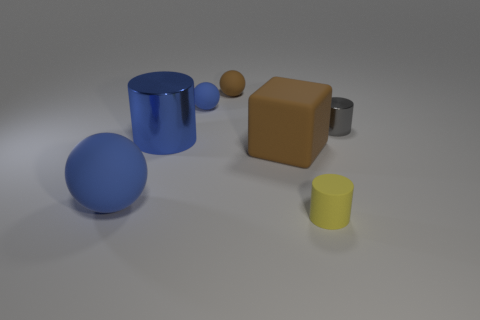Do the metal object that is in front of the gray shiny object and the tiny blue object have the same size?
Your response must be concise. No. Is the small metallic thing the same color as the big block?
Give a very brief answer. No. How many objects are things that are in front of the small brown sphere or blue objects?
Give a very brief answer. 6. What color is the large object that is the same shape as the tiny brown rubber thing?
Your answer should be compact. Blue. Does the big brown rubber object have the same shape as the small thing that is in front of the large blue ball?
Offer a very short reply. No. What number of objects are cylinders in front of the big metal cylinder or metal cylinders right of the large metallic cylinder?
Keep it short and to the point. 2. Are there fewer large brown objects that are in front of the large ball than small purple rubber balls?
Offer a terse response. No. Do the large brown object and the tiny cylinder that is left of the gray metal thing have the same material?
Your answer should be very brief. Yes. What material is the yellow object?
Your response must be concise. Rubber. What is the material of the blue sphere behind the large brown thing that is behind the object that is on the left side of the blue metal thing?
Provide a short and direct response. Rubber. 